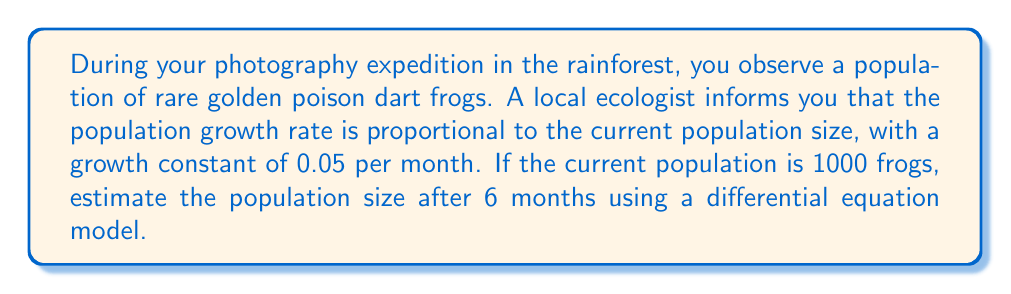Can you solve this math problem? Let's approach this step-by-step using a differential equation model:

1) Let $P(t)$ be the population size at time $t$ (in months).

2) The given information translates to the differential equation:

   $$\frac{dP}{dt} = 0.05P$$

   This is because the growth rate ($\frac{dP}{dt}$) is proportional to the current population ($P$) with a constant of 0.05.

3) This is a separable differential equation. We can solve it as follows:

   $$\frac{dP}{P} = 0.05dt$$

4) Integrating both sides:

   $$\int \frac{dP}{P} = \int 0.05dt$$

   $$\ln|P| = 0.05t + C$$

   Where $C$ is a constant of integration.

5) Taking the exponential of both sides:

   $$P = e^{0.05t + C} = e^C \cdot e^{0.05t}$$

6) Let $A = e^C$. Then our general solution is:

   $$P(t) = Ae^{0.05t}$$

7) We can find $A$ using the initial condition. At $t=0$, $P(0) = 1000$:

   $$1000 = Ae^{0.05 \cdot 0} = A$$

8) Therefore, our particular solution is:

   $$P(t) = 1000e^{0.05t}$$

9) To find the population after 6 months, we calculate $P(6)$:

   $$P(6) = 1000e^{0.05 \cdot 6} = 1000e^{0.3} \approx 1349.86$$

Therefore, after 6 months, the population will be approximately 1350 frogs (rounded to the nearest whole frog).
Answer: 1350 frogs 